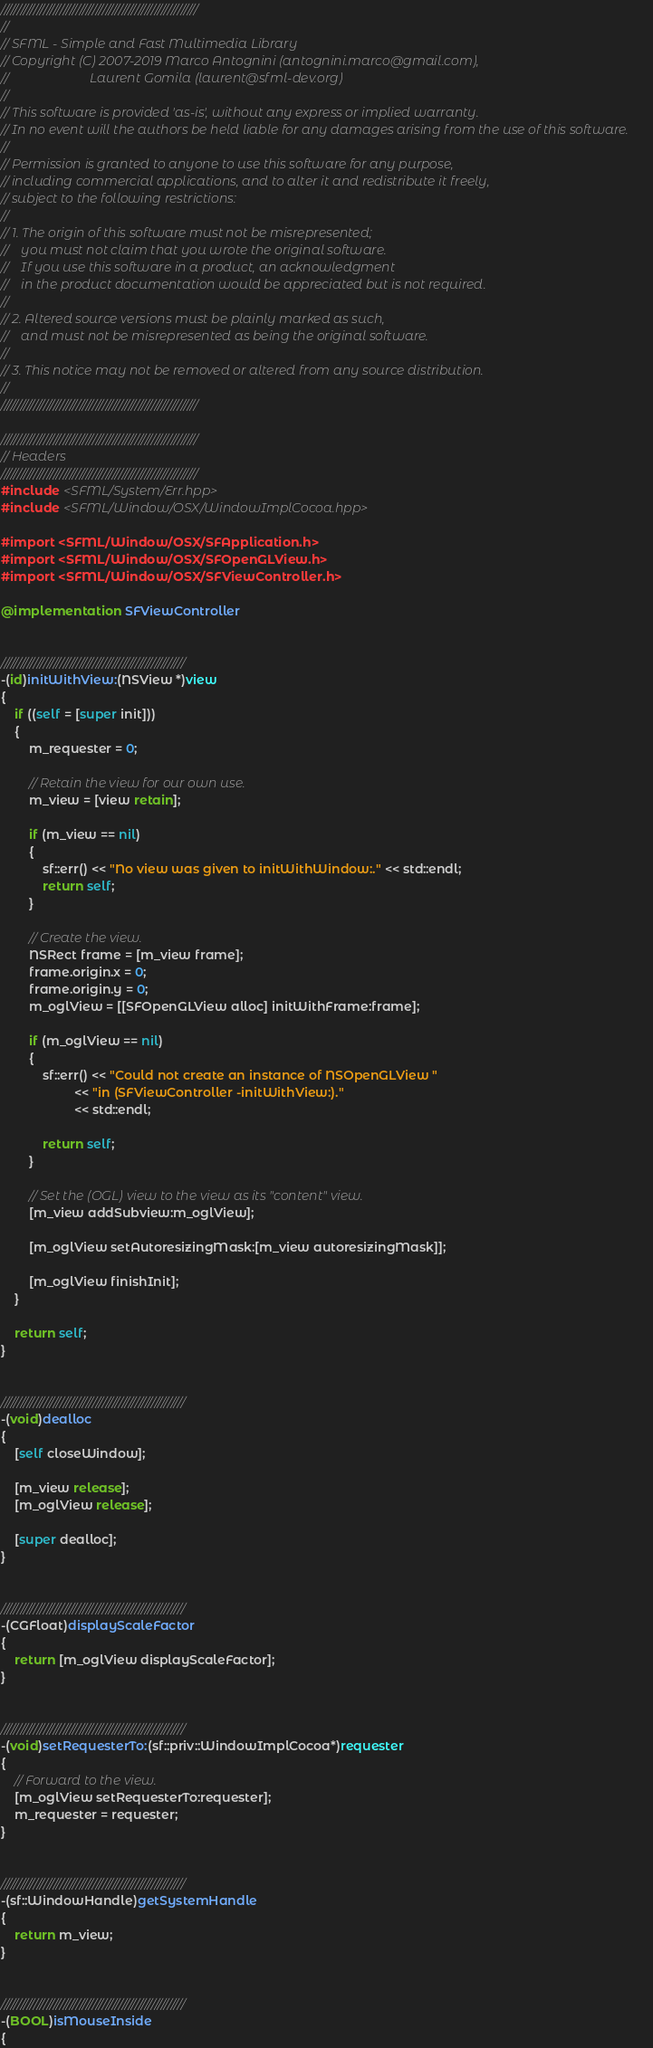<code> <loc_0><loc_0><loc_500><loc_500><_ObjectiveC_>////////////////////////////////////////////////////////////
//
// SFML - Simple and Fast Multimedia Library
// Copyright (C) 2007-2019 Marco Antognini (antognini.marco@gmail.com),
//                         Laurent Gomila (laurent@sfml-dev.org)
//
// This software is provided 'as-is', without any express or implied warranty.
// In no event will the authors be held liable for any damages arising from the use of this software.
//
// Permission is granted to anyone to use this software for any purpose,
// including commercial applications, and to alter it and redistribute it freely,
// subject to the following restrictions:
//
// 1. The origin of this software must not be misrepresented;
//    you must not claim that you wrote the original software.
//    If you use this software in a product, an acknowledgment
//    in the product documentation would be appreciated but is not required.
//
// 2. Altered source versions must be plainly marked as such,
//    and must not be misrepresented as being the original software.
//
// 3. This notice may not be removed or altered from any source distribution.
//
////////////////////////////////////////////////////////////

////////////////////////////////////////////////////////////
// Headers
////////////////////////////////////////////////////////////
#include <SFML/System/Err.hpp>
#include <SFML/Window/OSX/WindowImplCocoa.hpp>

#import <SFML/Window/OSX/SFApplication.h>
#import <SFML/Window/OSX/SFOpenGLView.h>
#import <SFML/Window/OSX/SFViewController.h>

@implementation SFViewController


////////////////////////////////////////////////////////
-(id)initWithView:(NSView *)view
{
    if ((self = [super init]))
    {
        m_requester = 0;

        // Retain the view for our own use.
        m_view = [view retain];

        if (m_view == nil)
        {
            sf::err() << "No view was given to initWithWindow:." << std::endl;
            return self;
        }

        // Create the view.
        NSRect frame = [m_view frame];
        frame.origin.x = 0;
        frame.origin.y = 0;
        m_oglView = [[SFOpenGLView alloc] initWithFrame:frame];

        if (m_oglView == nil)
        {
            sf::err() << "Could not create an instance of NSOpenGLView "
                     << "in (SFViewController -initWithView:)."
                     << std::endl;

            return self;
        }

        // Set the (OGL) view to the view as its "content" view.
        [m_view addSubview:m_oglView];

        [m_oglView setAutoresizingMask:[m_view autoresizingMask]];

        [m_oglView finishInit];
    }

    return self;
}


////////////////////////////////////////////////////////
-(void)dealloc
{
    [self closeWindow];

    [m_view release];
    [m_oglView release];

    [super dealloc];
}


////////////////////////////////////////////////////////
-(CGFloat)displayScaleFactor
{
    return [m_oglView displayScaleFactor];
}


////////////////////////////////////////////////////////
-(void)setRequesterTo:(sf::priv::WindowImplCocoa*)requester
{
    // Forward to the view.
    [m_oglView setRequesterTo:requester];
    m_requester = requester;
}


////////////////////////////////////////////////////////
-(sf::WindowHandle)getSystemHandle
{
    return m_view;
}


////////////////////////////////////////////////////////
-(BOOL)isMouseInside
{</code> 